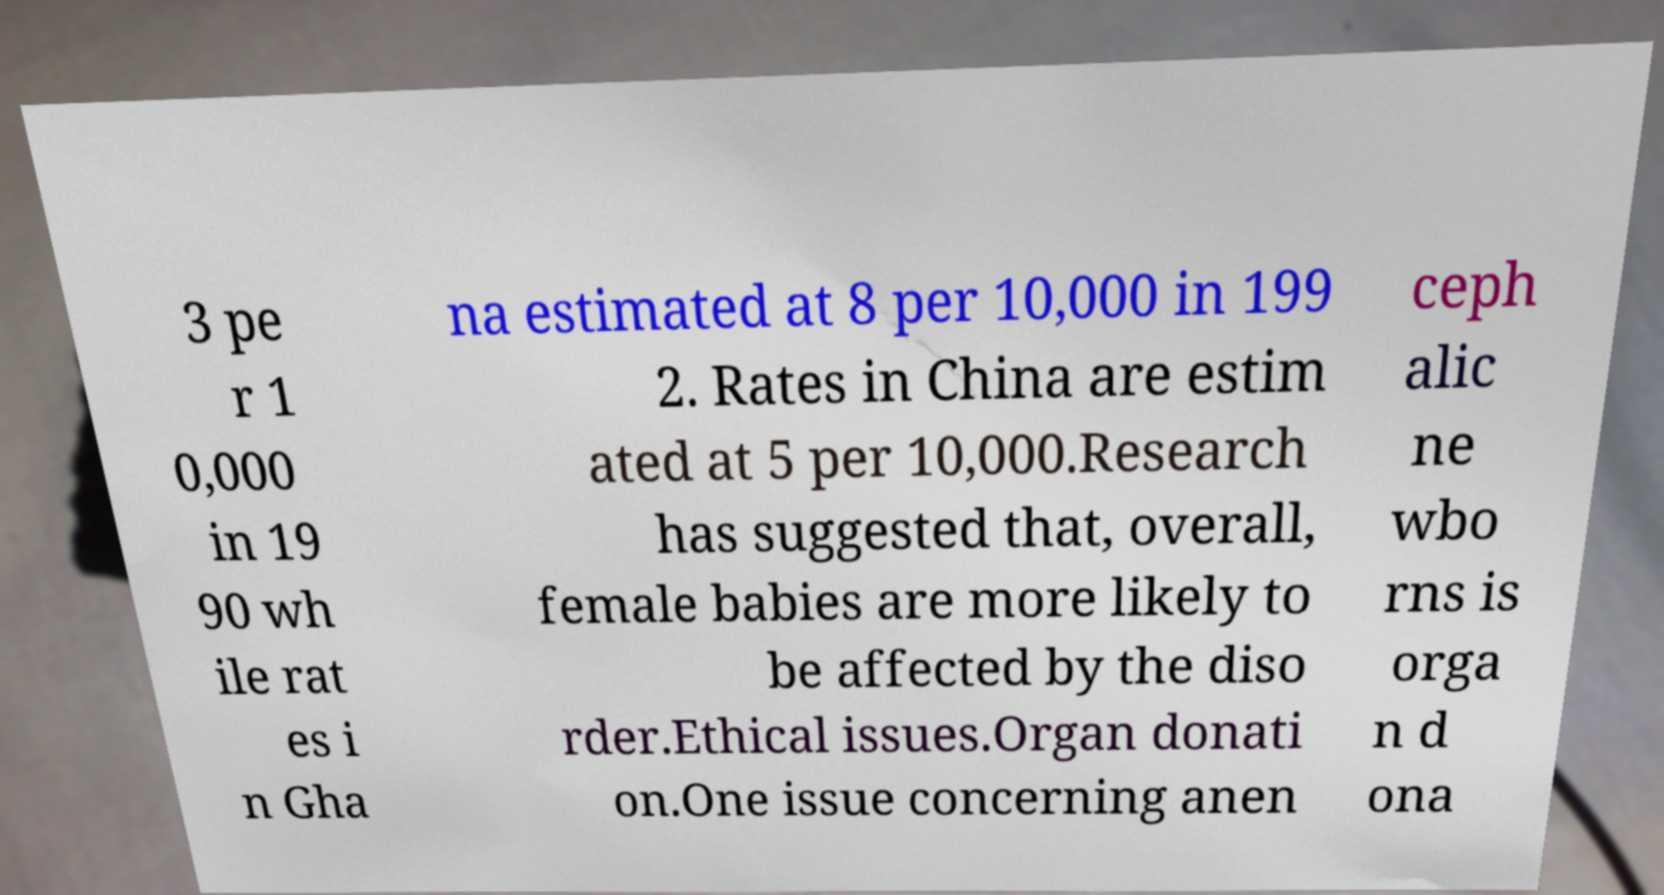For documentation purposes, I need the text within this image transcribed. Could you provide that? 3 pe r 1 0,000 in 19 90 wh ile rat es i n Gha na estimated at 8 per 10,000 in 199 2. Rates in China are estim ated at 5 per 10,000.Research has suggested that, overall, female babies are more likely to be affected by the diso rder.Ethical issues.Organ donati on.One issue concerning anen ceph alic ne wbo rns is orga n d ona 